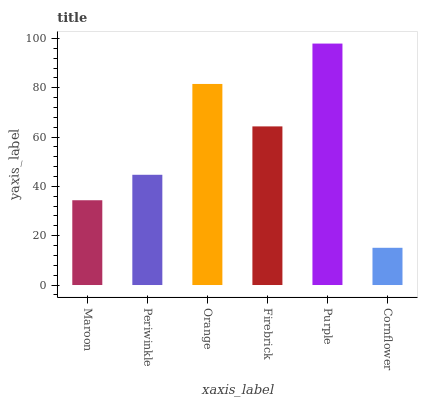Is Cornflower the minimum?
Answer yes or no. Yes. Is Purple the maximum?
Answer yes or no. Yes. Is Periwinkle the minimum?
Answer yes or no. No. Is Periwinkle the maximum?
Answer yes or no. No. Is Periwinkle greater than Maroon?
Answer yes or no. Yes. Is Maroon less than Periwinkle?
Answer yes or no. Yes. Is Maroon greater than Periwinkle?
Answer yes or no. No. Is Periwinkle less than Maroon?
Answer yes or no. No. Is Firebrick the high median?
Answer yes or no. Yes. Is Periwinkle the low median?
Answer yes or no. Yes. Is Orange the high median?
Answer yes or no. No. Is Maroon the low median?
Answer yes or no. No. 